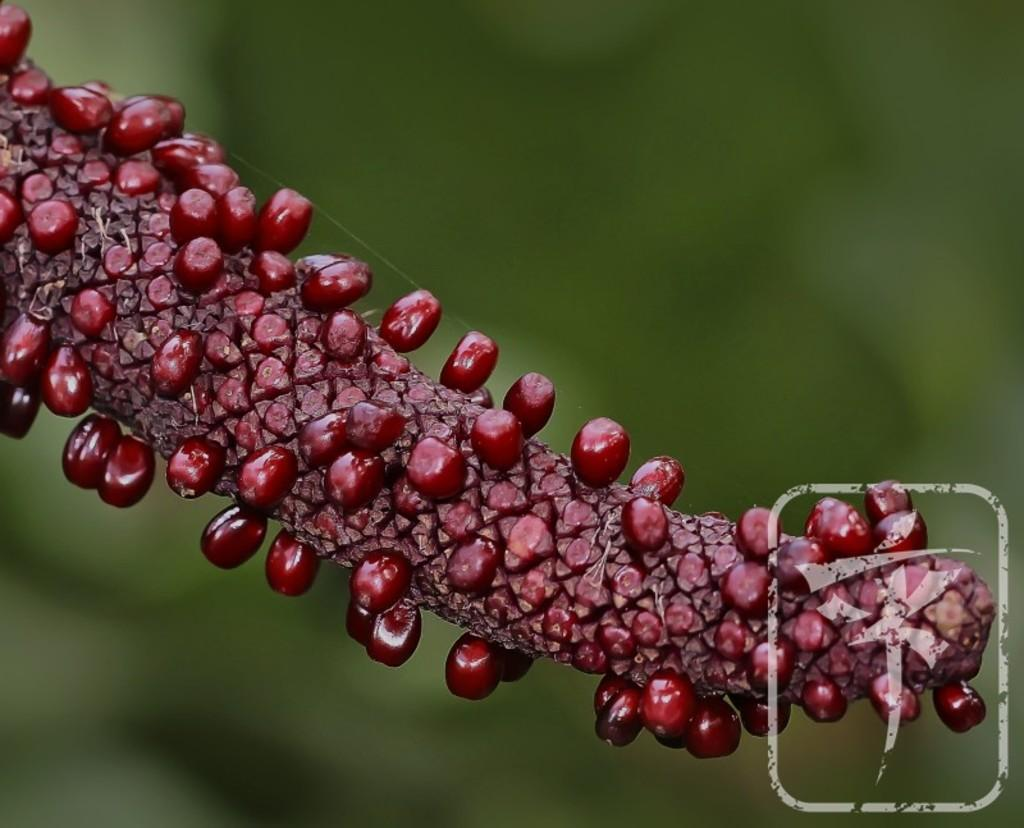What type of fruit is shown in the image? There are berries with a stem in the image. Can you describe the background of the image? The background is blurred. Is there any additional information or branding present in the image? Yes, there is a watermark at the bottom right side of the image. What type of flower is shown in the image? There is no flower present in the image; it features berries with a stem. What is the value of the item shown in the image? The value of the item cannot be determined from the image alone, as it does not provide any information about the price or worth of the berries. 